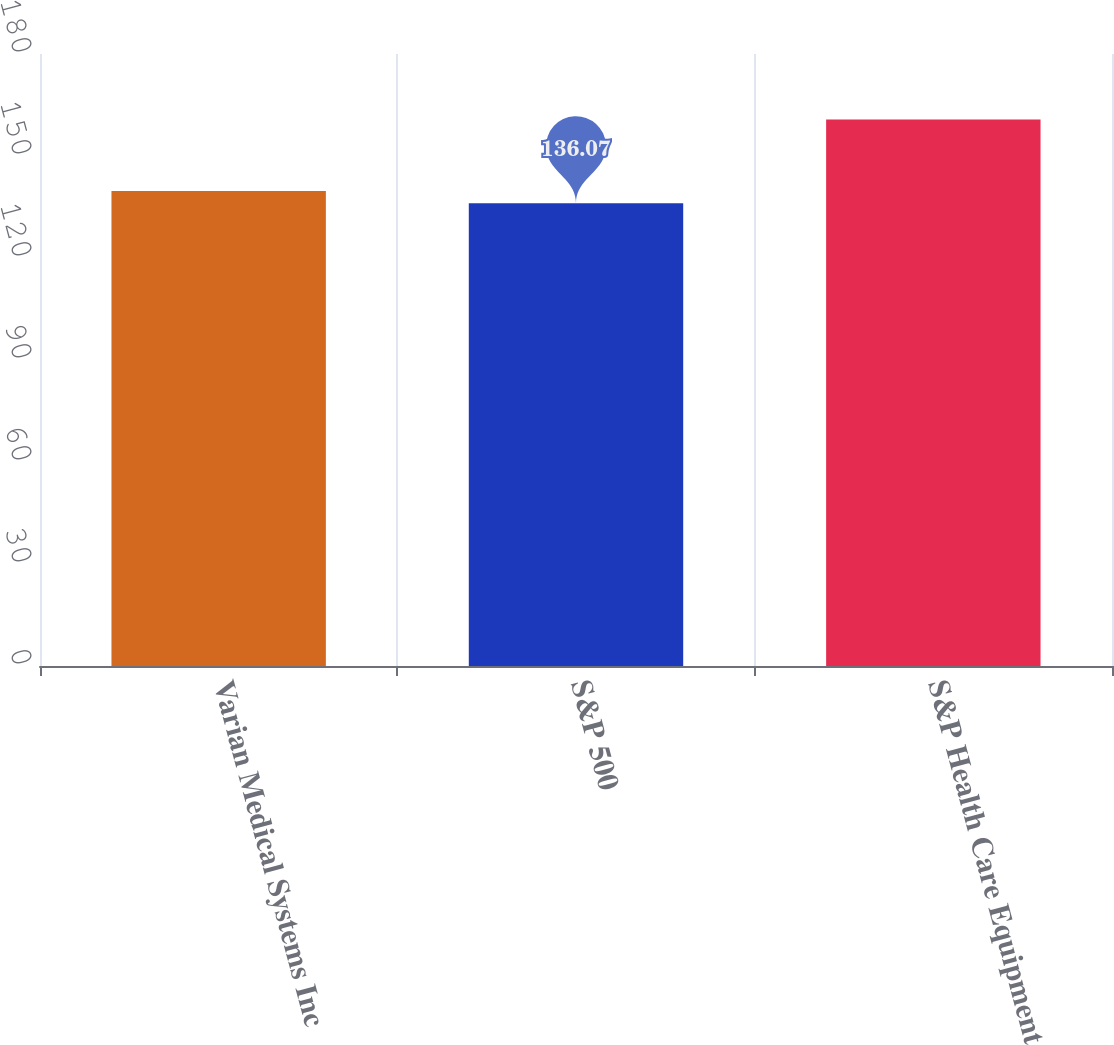<chart> <loc_0><loc_0><loc_500><loc_500><bar_chart><fcel>Varian Medical Systems Inc<fcel>S&P 500<fcel>S&P Health Care Equipment<nl><fcel>139.67<fcel>136.07<fcel>160.76<nl></chart> 